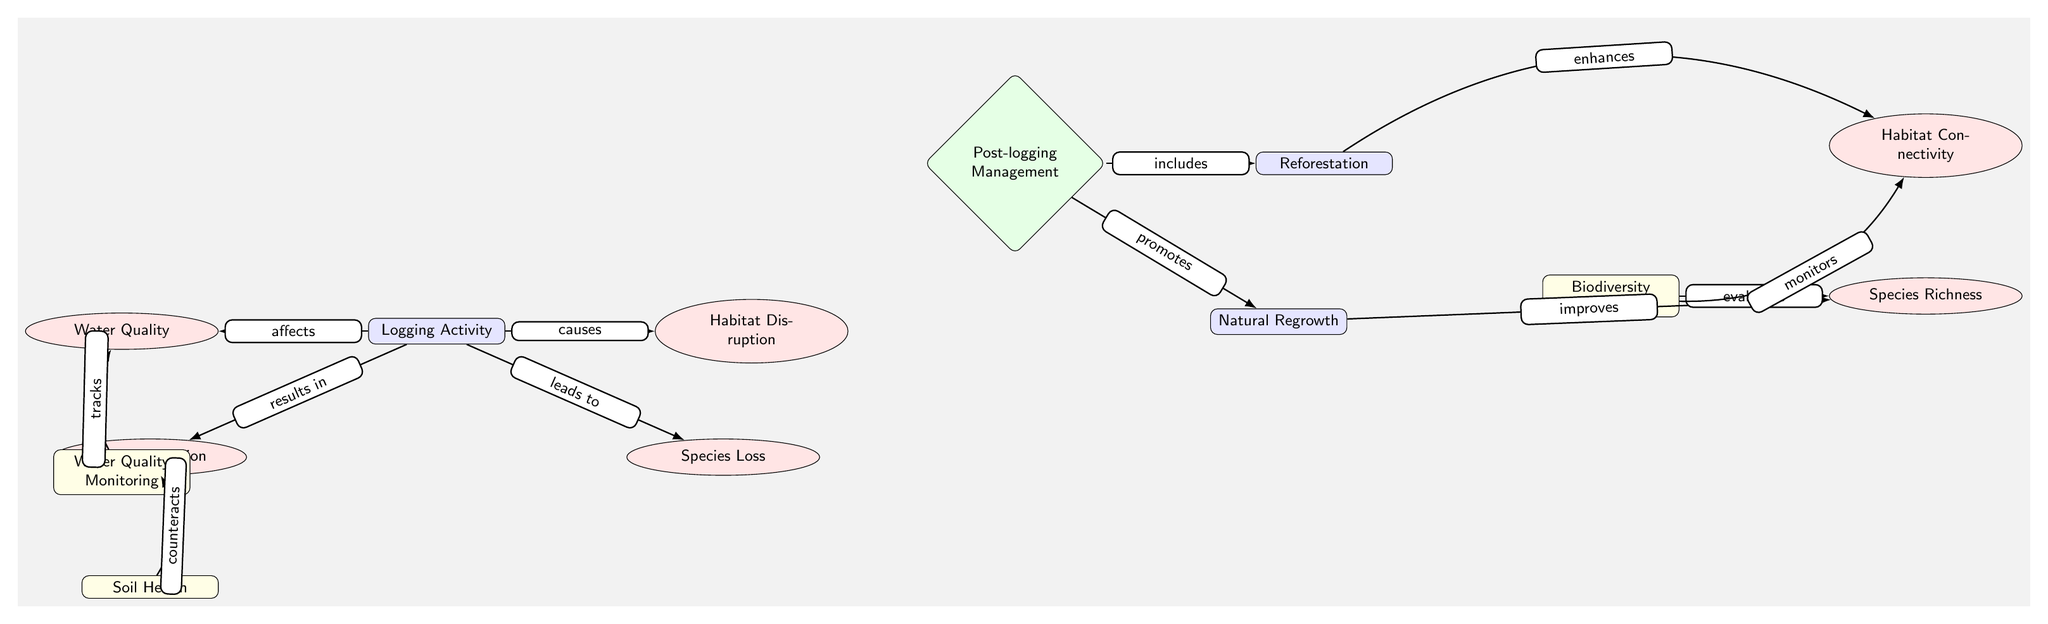What is the first node in the diagram? The first node in the diagram is labeled "Logging Activity." This can be identified as it is the topmost node and serves as the initial step in the outlined processes.
Answer: Logging Activity How many processes are represented in the diagram? To determine the number of processes, we count the nodes categorized as processes. There are three processes: "Logging Activity," "Reforestation," and "Natural Regrowth."
Answer: 3 What connection exists between "Post-logging Management" and "Reforestation"? The diagram indicates that "Post-logging Management" includes "Reforestation." This is shown by the directed edge connecting the management node to the reforestation node, which specifically states this relationship.
Answer: includes Which effect is related to "Soil Degradation"? The effect directly related to "Soil Degradation" is "Soil Health." The "Soil Health" assessment node edges out from the "Soil Degradation," indicating a relationship to counteract or address the degradation issue.
Answer: Soil Health What does the "Biodiversity Assessment" evaluate? According to the diagram, the "Biodiversity Assessment" evaluates "Species Richness." The relationship is indicated by the directed edge between these two nodes, showing that the assessment's purpose is to evaluate the richness of species in the ecosystem.
Answer: Species Richness What is the purpose of the "Water Quality Monitoring" node? The purpose of the "Water Quality Monitoring" node is to track water quality. This is represented by the directional edge leading from the "Water Quality Monitoring" node to the "Water Quality" node, denoting its role in monitoring the effects of logging on water quality.
Answer: tracks How does "Reforestation" affect "Habitat Connectivity"? "Reforestation" enhances "Habitat Connectivity," as indicated by the curved edge between the reforestation node and the connectivity node. This relationship suggests that reforestation activities contribute positively to connecting different habitats within the ecosystem.
Answer: enhances What action follows "Logging Activity"? The action that follows "Logging Activity" is "Habitat Disruption." This is shown in the diagram, where "Logging Activity" has a direct connection leading to "Habitat Disruption," illustrating a direct consequence of logging operations.
Answer: Habitat Disruption Which assessment monitors "Habitat Connectivity"? "Biodiversity Assessment" monitors "Habitat Connectivity." The directed edge in the diagram shows that this assessment is responsible for monitoring the level of connectivity in habitats after logging activities.
Answer: monitors 